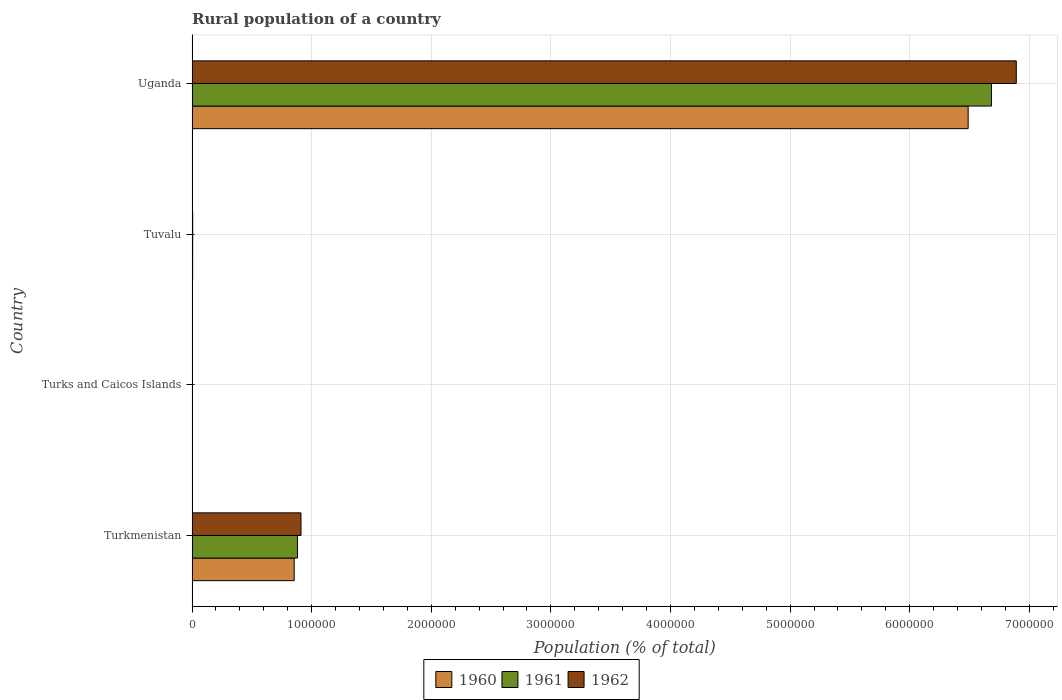How many different coloured bars are there?
Keep it short and to the point. 3. Are the number of bars on each tick of the Y-axis equal?
Your answer should be very brief. Yes. How many bars are there on the 2nd tick from the top?
Offer a very short reply. 3. How many bars are there on the 2nd tick from the bottom?
Provide a succinct answer. 3. What is the label of the 3rd group of bars from the top?
Ensure brevity in your answer.  Turks and Caicos Islands. What is the rural population in 1960 in Tuvalu?
Your response must be concise. 5134. Across all countries, what is the maximum rural population in 1962?
Give a very brief answer. 6.89e+06. Across all countries, what is the minimum rural population in 1960?
Give a very brief answer. 2995. In which country was the rural population in 1960 maximum?
Your answer should be compact. Uganda. In which country was the rural population in 1961 minimum?
Make the answer very short. Turks and Caicos Islands. What is the total rural population in 1960 in the graph?
Your response must be concise. 7.35e+06. What is the difference between the rural population in 1961 in Tuvalu and that in Uganda?
Your answer should be very brief. -6.68e+06. What is the difference between the rural population in 1960 in Uganda and the rural population in 1961 in Turkmenistan?
Give a very brief answer. 5.61e+06. What is the average rural population in 1961 per country?
Offer a very short reply. 1.89e+06. What is the difference between the rural population in 1960 and rural population in 1962 in Turks and Caicos Islands?
Make the answer very short. 20. In how many countries, is the rural population in 1961 greater than 3400000 %?
Offer a terse response. 1. What is the ratio of the rural population in 1960 in Turkmenistan to that in Uganda?
Offer a very short reply. 0.13. Is the rural population in 1962 in Turkmenistan less than that in Tuvalu?
Offer a terse response. No. What is the difference between the highest and the second highest rural population in 1961?
Provide a succinct answer. 5.80e+06. What is the difference between the highest and the lowest rural population in 1960?
Give a very brief answer. 6.49e+06. What does the 2nd bar from the bottom in Tuvalu represents?
Provide a succinct answer. 1961. How many bars are there?
Make the answer very short. 12. What is the difference between two consecutive major ticks on the X-axis?
Offer a terse response. 1.00e+06. Are the values on the major ticks of X-axis written in scientific E-notation?
Make the answer very short. No. Does the graph contain any zero values?
Make the answer very short. No. Where does the legend appear in the graph?
Your answer should be compact. Bottom center. How many legend labels are there?
Ensure brevity in your answer.  3. How are the legend labels stacked?
Provide a succinct answer. Horizontal. What is the title of the graph?
Your response must be concise. Rural population of a country. Does "1966" appear as one of the legend labels in the graph?
Keep it short and to the point. No. What is the label or title of the X-axis?
Provide a succinct answer. Population (% of total). What is the label or title of the Y-axis?
Provide a short and direct response. Country. What is the Population (% of total) in 1960 in Turkmenistan?
Provide a short and direct response. 8.54e+05. What is the Population (% of total) in 1961 in Turkmenistan?
Keep it short and to the point. 8.82e+05. What is the Population (% of total) of 1962 in Turkmenistan?
Make the answer very short. 9.11e+05. What is the Population (% of total) in 1960 in Turks and Caicos Islands?
Provide a short and direct response. 2995. What is the Population (% of total) of 1961 in Turks and Caicos Islands?
Your answer should be compact. 2994. What is the Population (% of total) in 1962 in Turks and Caicos Islands?
Provide a short and direct response. 2975. What is the Population (% of total) in 1960 in Tuvalu?
Keep it short and to the point. 5134. What is the Population (% of total) of 1961 in Tuvalu?
Your response must be concise. 5216. What is the Population (% of total) in 1962 in Tuvalu?
Keep it short and to the point. 5304. What is the Population (% of total) of 1960 in Uganda?
Offer a terse response. 6.49e+06. What is the Population (% of total) in 1961 in Uganda?
Offer a very short reply. 6.68e+06. What is the Population (% of total) in 1962 in Uganda?
Make the answer very short. 6.89e+06. Across all countries, what is the maximum Population (% of total) in 1960?
Offer a terse response. 6.49e+06. Across all countries, what is the maximum Population (% of total) in 1961?
Make the answer very short. 6.68e+06. Across all countries, what is the maximum Population (% of total) in 1962?
Offer a terse response. 6.89e+06. Across all countries, what is the minimum Population (% of total) in 1960?
Ensure brevity in your answer.  2995. Across all countries, what is the minimum Population (% of total) of 1961?
Your response must be concise. 2994. Across all countries, what is the minimum Population (% of total) in 1962?
Your answer should be very brief. 2975. What is the total Population (% of total) of 1960 in the graph?
Provide a short and direct response. 7.35e+06. What is the total Population (% of total) in 1961 in the graph?
Your answer should be compact. 7.57e+06. What is the total Population (% of total) of 1962 in the graph?
Offer a very short reply. 7.81e+06. What is the difference between the Population (% of total) in 1960 in Turkmenistan and that in Turks and Caicos Islands?
Give a very brief answer. 8.51e+05. What is the difference between the Population (% of total) of 1961 in Turkmenistan and that in Turks and Caicos Islands?
Keep it short and to the point. 8.79e+05. What is the difference between the Population (% of total) in 1962 in Turkmenistan and that in Turks and Caicos Islands?
Your response must be concise. 9.08e+05. What is the difference between the Population (% of total) in 1960 in Turkmenistan and that in Tuvalu?
Offer a terse response. 8.49e+05. What is the difference between the Population (% of total) in 1961 in Turkmenistan and that in Tuvalu?
Ensure brevity in your answer.  8.77e+05. What is the difference between the Population (% of total) in 1962 in Turkmenistan and that in Tuvalu?
Offer a very short reply. 9.05e+05. What is the difference between the Population (% of total) in 1960 in Turkmenistan and that in Uganda?
Your answer should be very brief. -5.63e+06. What is the difference between the Population (% of total) in 1961 in Turkmenistan and that in Uganda?
Ensure brevity in your answer.  -5.80e+06. What is the difference between the Population (% of total) of 1962 in Turkmenistan and that in Uganda?
Offer a very short reply. -5.98e+06. What is the difference between the Population (% of total) in 1960 in Turks and Caicos Islands and that in Tuvalu?
Offer a very short reply. -2139. What is the difference between the Population (% of total) in 1961 in Turks and Caicos Islands and that in Tuvalu?
Make the answer very short. -2222. What is the difference between the Population (% of total) in 1962 in Turks and Caicos Islands and that in Tuvalu?
Your response must be concise. -2329. What is the difference between the Population (% of total) in 1960 in Turks and Caicos Islands and that in Uganda?
Offer a very short reply. -6.49e+06. What is the difference between the Population (% of total) in 1961 in Turks and Caicos Islands and that in Uganda?
Your answer should be compact. -6.68e+06. What is the difference between the Population (% of total) of 1962 in Turks and Caicos Islands and that in Uganda?
Your answer should be very brief. -6.89e+06. What is the difference between the Population (% of total) in 1960 in Tuvalu and that in Uganda?
Your response must be concise. -6.48e+06. What is the difference between the Population (% of total) in 1961 in Tuvalu and that in Uganda?
Your response must be concise. -6.68e+06. What is the difference between the Population (% of total) of 1962 in Tuvalu and that in Uganda?
Give a very brief answer. -6.89e+06. What is the difference between the Population (% of total) of 1960 in Turkmenistan and the Population (% of total) of 1961 in Turks and Caicos Islands?
Your answer should be compact. 8.51e+05. What is the difference between the Population (% of total) in 1960 in Turkmenistan and the Population (% of total) in 1962 in Turks and Caicos Islands?
Make the answer very short. 8.51e+05. What is the difference between the Population (% of total) of 1961 in Turkmenistan and the Population (% of total) of 1962 in Turks and Caicos Islands?
Offer a very short reply. 8.79e+05. What is the difference between the Population (% of total) of 1960 in Turkmenistan and the Population (% of total) of 1961 in Tuvalu?
Offer a terse response. 8.49e+05. What is the difference between the Population (% of total) of 1960 in Turkmenistan and the Population (% of total) of 1962 in Tuvalu?
Your response must be concise. 8.49e+05. What is the difference between the Population (% of total) of 1961 in Turkmenistan and the Population (% of total) of 1962 in Tuvalu?
Offer a terse response. 8.76e+05. What is the difference between the Population (% of total) in 1960 in Turkmenistan and the Population (% of total) in 1961 in Uganda?
Your answer should be very brief. -5.83e+06. What is the difference between the Population (% of total) in 1960 in Turkmenistan and the Population (% of total) in 1962 in Uganda?
Provide a short and direct response. -6.04e+06. What is the difference between the Population (% of total) of 1961 in Turkmenistan and the Population (% of total) of 1962 in Uganda?
Provide a short and direct response. -6.01e+06. What is the difference between the Population (% of total) of 1960 in Turks and Caicos Islands and the Population (% of total) of 1961 in Tuvalu?
Give a very brief answer. -2221. What is the difference between the Population (% of total) in 1960 in Turks and Caicos Islands and the Population (% of total) in 1962 in Tuvalu?
Provide a succinct answer. -2309. What is the difference between the Population (% of total) in 1961 in Turks and Caicos Islands and the Population (% of total) in 1962 in Tuvalu?
Offer a terse response. -2310. What is the difference between the Population (% of total) of 1960 in Turks and Caicos Islands and the Population (% of total) of 1961 in Uganda?
Keep it short and to the point. -6.68e+06. What is the difference between the Population (% of total) in 1960 in Turks and Caicos Islands and the Population (% of total) in 1962 in Uganda?
Offer a very short reply. -6.89e+06. What is the difference between the Population (% of total) of 1961 in Turks and Caicos Islands and the Population (% of total) of 1962 in Uganda?
Offer a very short reply. -6.89e+06. What is the difference between the Population (% of total) in 1960 in Tuvalu and the Population (% of total) in 1961 in Uganda?
Make the answer very short. -6.68e+06. What is the difference between the Population (% of total) of 1960 in Tuvalu and the Population (% of total) of 1962 in Uganda?
Your response must be concise. -6.89e+06. What is the difference between the Population (% of total) in 1961 in Tuvalu and the Population (% of total) in 1962 in Uganda?
Offer a terse response. -6.89e+06. What is the average Population (% of total) in 1960 per country?
Make the answer very short. 1.84e+06. What is the average Population (% of total) of 1961 per country?
Your answer should be compact. 1.89e+06. What is the average Population (% of total) of 1962 per country?
Your answer should be very brief. 1.95e+06. What is the difference between the Population (% of total) of 1960 and Population (% of total) of 1961 in Turkmenistan?
Make the answer very short. -2.78e+04. What is the difference between the Population (% of total) of 1960 and Population (% of total) of 1962 in Turkmenistan?
Provide a short and direct response. -5.68e+04. What is the difference between the Population (% of total) in 1961 and Population (% of total) in 1962 in Turkmenistan?
Your answer should be compact. -2.89e+04. What is the difference between the Population (% of total) of 1961 and Population (% of total) of 1962 in Turks and Caicos Islands?
Offer a terse response. 19. What is the difference between the Population (% of total) in 1960 and Population (% of total) in 1961 in Tuvalu?
Your answer should be compact. -82. What is the difference between the Population (% of total) of 1960 and Population (% of total) of 1962 in Tuvalu?
Provide a succinct answer. -170. What is the difference between the Population (% of total) in 1961 and Population (% of total) in 1962 in Tuvalu?
Provide a succinct answer. -88. What is the difference between the Population (% of total) of 1960 and Population (% of total) of 1961 in Uganda?
Offer a very short reply. -1.95e+05. What is the difference between the Population (% of total) in 1960 and Population (% of total) in 1962 in Uganda?
Keep it short and to the point. -4.02e+05. What is the difference between the Population (% of total) in 1961 and Population (% of total) in 1962 in Uganda?
Ensure brevity in your answer.  -2.08e+05. What is the ratio of the Population (% of total) in 1960 in Turkmenistan to that in Turks and Caicos Islands?
Offer a very short reply. 285.12. What is the ratio of the Population (% of total) of 1961 in Turkmenistan to that in Turks and Caicos Islands?
Offer a very short reply. 294.51. What is the ratio of the Population (% of total) in 1962 in Turkmenistan to that in Turks and Caicos Islands?
Ensure brevity in your answer.  306.12. What is the ratio of the Population (% of total) of 1960 in Turkmenistan to that in Tuvalu?
Your response must be concise. 166.33. What is the ratio of the Population (% of total) of 1961 in Turkmenistan to that in Tuvalu?
Ensure brevity in your answer.  169.05. What is the ratio of the Population (% of total) of 1962 in Turkmenistan to that in Tuvalu?
Provide a short and direct response. 171.7. What is the ratio of the Population (% of total) in 1960 in Turkmenistan to that in Uganda?
Offer a terse response. 0.13. What is the ratio of the Population (% of total) of 1961 in Turkmenistan to that in Uganda?
Ensure brevity in your answer.  0.13. What is the ratio of the Population (% of total) of 1962 in Turkmenistan to that in Uganda?
Provide a succinct answer. 0.13. What is the ratio of the Population (% of total) of 1960 in Turks and Caicos Islands to that in Tuvalu?
Make the answer very short. 0.58. What is the ratio of the Population (% of total) of 1961 in Turks and Caicos Islands to that in Tuvalu?
Give a very brief answer. 0.57. What is the ratio of the Population (% of total) of 1962 in Turks and Caicos Islands to that in Tuvalu?
Make the answer very short. 0.56. What is the ratio of the Population (% of total) in 1960 in Turks and Caicos Islands to that in Uganda?
Ensure brevity in your answer.  0. What is the ratio of the Population (% of total) of 1960 in Tuvalu to that in Uganda?
Keep it short and to the point. 0. What is the ratio of the Population (% of total) of 1961 in Tuvalu to that in Uganda?
Keep it short and to the point. 0. What is the ratio of the Population (% of total) in 1962 in Tuvalu to that in Uganda?
Ensure brevity in your answer.  0. What is the difference between the highest and the second highest Population (% of total) in 1960?
Keep it short and to the point. 5.63e+06. What is the difference between the highest and the second highest Population (% of total) in 1961?
Your answer should be very brief. 5.80e+06. What is the difference between the highest and the second highest Population (% of total) of 1962?
Provide a succinct answer. 5.98e+06. What is the difference between the highest and the lowest Population (% of total) in 1960?
Provide a short and direct response. 6.49e+06. What is the difference between the highest and the lowest Population (% of total) of 1961?
Your answer should be compact. 6.68e+06. What is the difference between the highest and the lowest Population (% of total) in 1962?
Your answer should be very brief. 6.89e+06. 